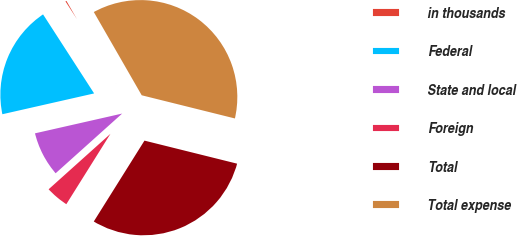Convert chart to OTSL. <chart><loc_0><loc_0><loc_500><loc_500><pie_chart><fcel>in thousands<fcel>Federal<fcel>State and local<fcel>Foreign<fcel>Total<fcel>Total expense<nl><fcel>0.82%<fcel>19.42%<fcel>8.09%<fcel>4.45%<fcel>30.03%<fcel>37.19%<nl></chart> 